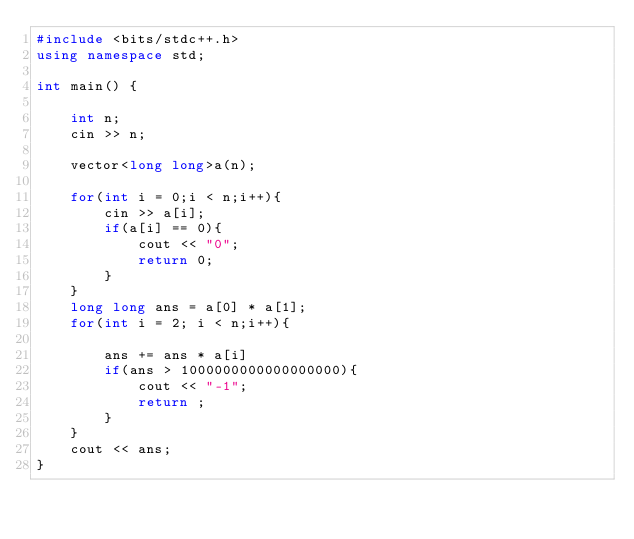Convert code to text. <code><loc_0><loc_0><loc_500><loc_500><_C++_>#include <bits/stdc++.h>
using namespace std;

int main() {

    int n;
    cin >> n;

    vector<long long>a(n);
    
    for(int i = 0;i < n;i++){
        cin >> a[i];
        if(a[i] == 0){
            cout << "0";
            return 0;
        }
    }
    long long ans = a[0] * a[1];
    for(int i = 2; i < n;i++){

        ans += ans * a[i]
        if(ans > 1000000000000000000){
            cout << "-1";
            return ;
        }
    }
    cout << ans;
}</code> 